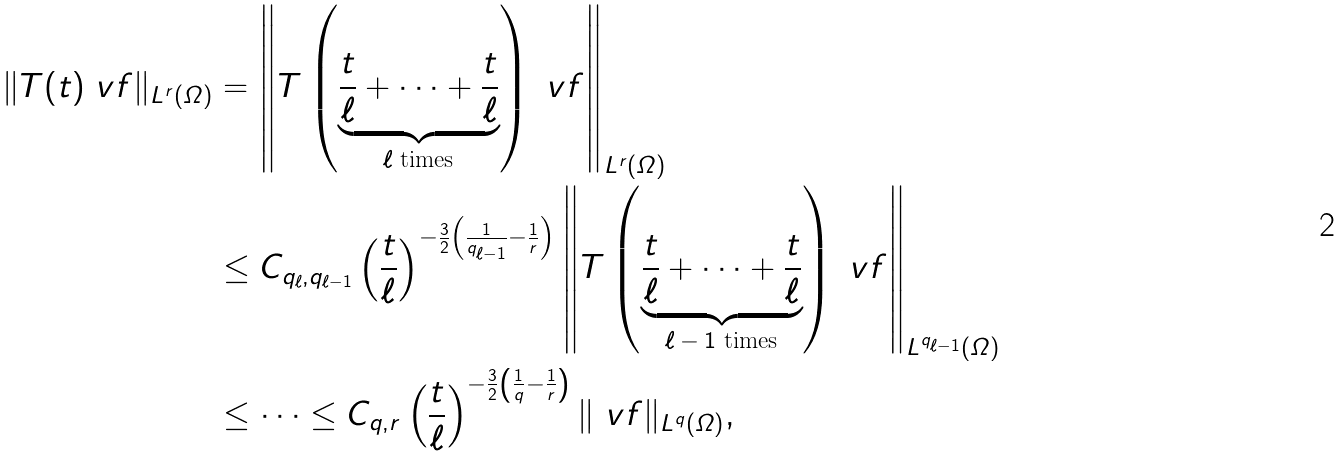Convert formula to latex. <formula><loc_0><loc_0><loc_500><loc_500>\| T ( t ) \ v f \| _ { L ^ { r } ( \varOmega ) } & = \left \| T \left ( \underbrace { \frac { t } { \ell } + \cdots + \frac { t } { \ell } } _ { \text {$\ell$ times} } \right ) \ v f \right \| _ { L ^ { r } ( \varOmega ) } \\ & \leq C _ { q _ { \ell } , q _ { \ell - 1 } } \left ( \frac { t } { \ell } \right ) ^ { - \frac { 3 } { 2 } \left ( \frac { 1 } { q _ { \ell - 1 } } - \frac { 1 } { r } \right ) } \left \| T \left ( \underbrace { \frac { t } { \ell } + \cdots + \frac { t } { \ell } } _ { \text {$\ell-1$ times} } \right ) \ v f \right \| _ { L ^ { q _ { \ell - 1 } } ( \varOmega ) } \\ & \leq \dots \leq C _ { q , r } \left ( \frac { t } { \ell } \right ) ^ { - \frac { 3 } { 2 } \left ( \frac { 1 } { q } - \frac { 1 } { r } \right ) } \| \ v f \| _ { L ^ { q } ( \varOmega ) } ,</formula> 